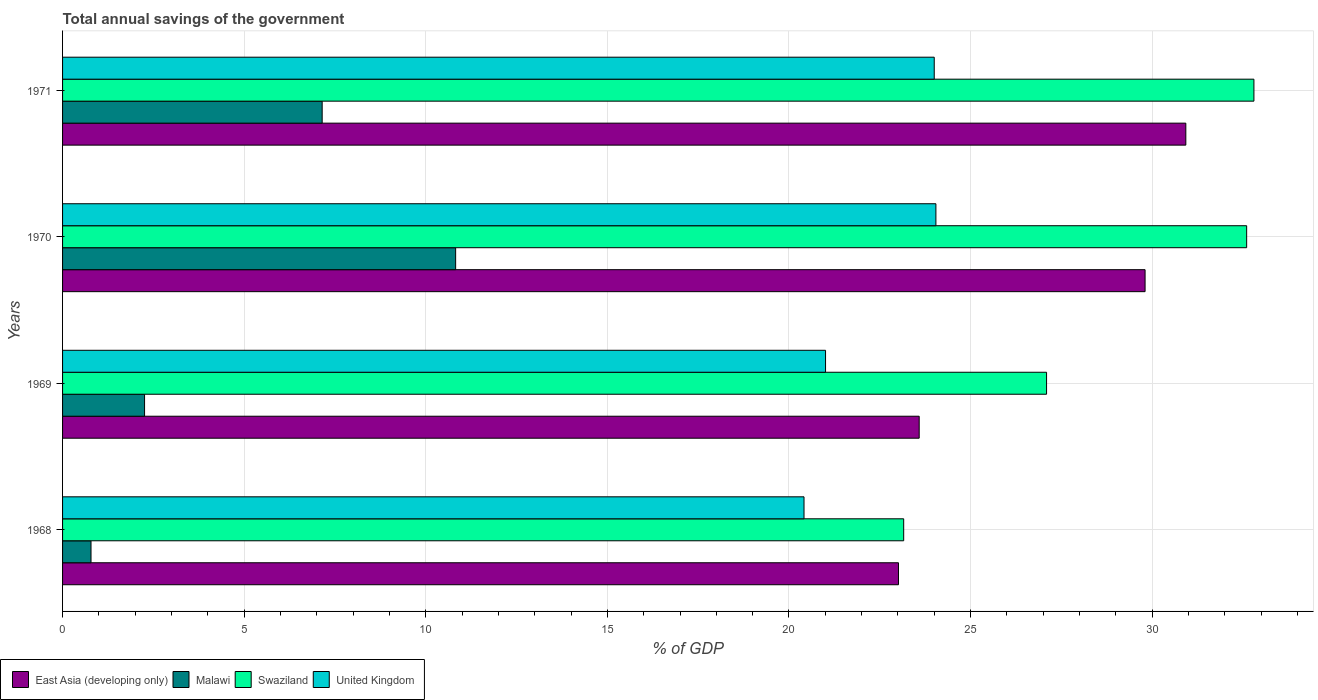How many different coloured bars are there?
Ensure brevity in your answer.  4. How many bars are there on the 4th tick from the bottom?
Your answer should be compact. 4. What is the label of the 2nd group of bars from the top?
Provide a succinct answer. 1970. In how many cases, is the number of bars for a given year not equal to the number of legend labels?
Ensure brevity in your answer.  0. What is the total annual savings of the government in Swaziland in 1968?
Ensure brevity in your answer.  23.16. Across all years, what is the maximum total annual savings of the government in Swaziland?
Give a very brief answer. 32.8. Across all years, what is the minimum total annual savings of the government in East Asia (developing only)?
Offer a terse response. 23.01. In which year was the total annual savings of the government in United Kingdom minimum?
Make the answer very short. 1968. What is the total total annual savings of the government in East Asia (developing only) in the graph?
Offer a very short reply. 107.33. What is the difference between the total annual savings of the government in Malawi in 1969 and that in 1970?
Ensure brevity in your answer.  -8.56. What is the difference between the total annual savings of the government in East Asia (developing only) in 1971 and the total annual savings of the government in Malawi in 1968?
Your answer should be compact. 30.14. What is the average total annual savings of the government in East Asia (developing only) per year?
Your answer should be compact. 26.83. In the year 1968, what is the difference between the total annual savings of the government in East Asia (developing only) and total annual savings of the government in Swaziland?
Offer a very short reply. -0.14. What is the ratio of the total annual savings of the government in East Asia (developing only) in 1968 to that in 1970?
Your response must be concise. 0.77. Is the total annual savings of the government in Malawi in 1969 less than that in 1971?
Offer a terse response. Yes. What is the difference between the highest and the second highest total annual savings of the government in Malawi?
Keep it short and to the point. 3.67. What is the difference between the highest and the lowest total annual savings of the government in United Kingdom?
Your answer should be compact. 3.63. In how many years, is the total annual savings of the government in Malawi greater than the average total annual savings of the government in Malawi taken over all years?
Ensure brevity in your answer.  2. Is the sum of the total annual savings of the government in United Kingdom in 1968 and 1971 greater than the maximum total annual savings of the government in Malawi across all years?
Your answer should be compact. Yes. What does the 2nd bar from the bottom in 1971 represents?
Your answer should be compact. Malawi. Is it the case that in every year, the sum of the total annual savings of the government in Swaziland and total annual savings of the government in East Asia (developing only) is greater than the total annual savings of the government in United Kingdom?
Ensure brevity in your answer.  Yes. How many years are there in the graph?
Your answer should be very brief. 4. Are the values on the major ticks of X-axis written in scientific E-notation?
Your answer should be very brief. No. Does the graph contain any zero values?
Ensure brevity in your answer.  No. Where does the legend appear in the graph?
Provide a succinct answer. Bottom left. How many legend labels are there?
Offer a very short reply. 4. What is the title of the graph?
Provide a short and direct response. Total annual savings of the government. Does "Curacao" appear as one of the legend labels in the graph?
Offer a very short reply. No. What is the label or title of the X-axis?
Your answer should be compact. % of GDP. What is the % of GDP in East Asia (developing only) in 1968?
Ensure brevity in your answer.  23.01. What is the % of GDP in Malawi in 1968?
Offer a terse response. 0.78. What is the % of GDP of Swaziland in 1968?
Offer a terse response. 23.16. What is the % of GDP in United Kingdom in 1968?
Ensure brevity in your answer.  20.41. What is the % of GDP in East Asia (developing only) in 1969?
Offer a terse response. 23.58. What is the % of GDP of Malawi in 1969?
Ensure brevity in your answer.  2.26. What is the % of GDP in Swaziland in 1969?
Provide a short and direct response. 27.09. What is the % of GDP in United Kingdom in 1969?
Provide a succinct answer. 21.01. What is the % of GDP in East Asia (developing only) in 1970?
Offer a very short reply. 29.8. What is the % of GDP in Malawi in 1970?
Make the answer very short. 10.82. What is the % of GDP in Swaziland in 1970?
Offer a very short reply. 32.6. What is the % of GDP in United Kingdom in 1970?
Give a very brief answer. 24.04. What is the % of GDP in East Asia (developing only) in 1971?
Offer a very short reply. 30.93. What is the % of GDP of Malawi in 1971?
Your answer should be compact. 7.15. What is the % of GDP of Swaziland in 1971?
Your answer should be very brief. 32.8. What is the % of GDP in United Kingdom in 1971?
Provide a short and direct response. 24. Across all years, what is the maximum % of GDP in East Asia (developing only)?
Ensure brevity in your answer.  30.93. Across all years, what is the maximum % of GDP of Malawi?
Offer a terse response. 10.82. Across all years, what is the maximum % of GDP in Swaziland?
Ensure brevity in your answer.  32.8. Across all years, what is the maximum % of GDP of United Kingdom?
Offer a terse response. 24.04. Across all years, what is the minimum % of GDP of East Asia (developing only)?
Provide a succinct answer. 23.01. Across all years, what is the minimum % of GDP of Malawi?
Your answer should be compact. 0.78. Across all years, what is the minimum % of GDP of Swaziland?
Ensure brevity in your answer.  23.16. Across all years, what is the minimum % of GDP in United Kingdom?
Provide a succinct answer. 20.41. What is the total % of GDP of East Asia (developing only) in the graph?
Offer a terse response. 107.33. What is the total % of GDP of Malawi in the graph?
Your answer should be compact. 21.01. What is the total % of GDP of Swaziland in the graph?
Your answer should be very brief. 115.65. What is the total % of GDP of United Kingdom in the graph?
Keep it short and to the point. 89.46. What is the difference between the % of GDP in East Asia (developing only) in 1968 and that in 1969?
Your answer should be compact. -0.57. What is the difference between the % of GDP in Malawi in 1968 and that in 1969?
Ensure brevity in your answer.  -1.47. What is the difference between the % of GDP of Swaziland in 1968 and that in 1969?
Keep it short and to the point. -3.93. What is the difference between the % of GDP in United Kingdom in 1968 and that in 1969?
Provide a short and direct response. -0.59. What is the difference between the % of GDP in East Asia (developing only) in 1968 and that in 1970?
Ensure brevity in your answer.  -6.79. What is the difference between the % of GDP in Malawi in 1968 and that in 1970?
Offer a terse response. -10.04. What is the difference between the % of GDP in Swaziland in 1968 and that in 1970?
Provide a short and direct response. -9.44. What is the difference between the % of GDP of United Kingdom in 1968 and that in 1970?
Provide a succinct answer. -3.63. What is the difference between the % of GDP of East Asia (developing only) in 1968 and that in 1971?
Your answer should be compact. -7.91. What is the difference between the % of GDP in Malawi in 1968 and that in 1971?
Provide a short and direct response. -6.36. What is the difference between the % of GDP of Swaziland in 1968 and that in 1971?
Your answer should be compact. -9.64. What is the difference between the % of GDP in United Kingdom in 1968 and that in 1971?
Make the answer very short. -3.59. What is the difference between the % of GDP of East Asia (developing only) in 1969 and that in 1970?
Your response must be concise. -6.22. What is the difference between the % of GDP of Malawi in 1969 and that in 1970?
Offer a terse response. -8.56. What is the difference between the % of GDP of Swaziland in 1969 and that in 1970?
Give a very brief answer. -5.51. What is the difference between the % of GDP of United Kingdom in 1969 and that in 1970?
Provide a short and direct response. -3.04. What is the difference between the % of GDP of East Asia (developing only) in 1969 and that in 1971?
Give a very brief answer. -7.34. What is the difference between the % of GDP of Malawi in 1969 and that in 1971?
Keep it short and to the point. -4.89. What is the difference between the % of GDP of Swaziland in 1969 and that in 1971?
Give a very brief answer. -5.71. What is the difference between the % of GDP of United Kingdom in 1969 and that in 1971?
Make the answer very short. -2.99. What is the difference between the % of GDP in East Asia (developing only) in 1970 and that in 1971?
Keep it short and to the point. -1.12. What is the difference between the % of GDP in Malawi in 1970 and that in 1971?
Keep it short and to the point. 3.67. What is the difference between the % of GDP of Swaziland in 1970 and that in 1971?
Your answer should be compact. -0.2. What is the difference between the % of GDP in United Kingdom in 1970 and that in 1971?
Your response must be concise. 0.05. What is the difference between the % of GDP of East Asia (developing only) in 1968 and the % of GDP of Malawi in 1969?
Provide a succinct answer. 20.76. What is the difference between the % of GDP in East Asia (developing only) in 1968 and the % of GDP in Swaziland in 1969?
Your response must be concise. -4.08. What is the difference between the % of GDP of East Asia (developing only) in 1968 and the % of GDP of United Kingdom in 1969?
Your response must be concise. 2.01. What is the difference between the % of GDP of Malawi in 1968 and the % of GDP of Swaziland in 1969?
Provide a short and direct response. -26.31. What is the difference between the % of GDP in Malawi in 1968 and the % of GDP in United Kingdom in 1969?
Make the answer very short. -20.22. What is the difference between the % of GDP in Swaziland in 1968 and the % of GDP in United Kingdom in 1969?
Make the answer very short. 2.15. What is the difference between the % of GDP of East Asia (developing only) in 1968 and the % of GDP of Malawi in 1970?
Provide a succinct answer. 12.19. What is the difference between the % of GDP in East Asia (developing only) in 1968 and the % of GDP in Swaziland in 1970?
Give a very brief answer. -9.59. What is the difference between the % of GDP of East Asia (developing only) in 1968 and the % of GDP of United Kingdom in 1970?
Your answer should be compact. -1.03. What is the difference between the % of GDP of Malawi in 1968 and the % of GDP of Swaziland in 1970?
Give a very brief answer. -31.82. What is the difference between the % of GDP in Malawi in 1968 and the % of GDP in United Kingdom in 1970?
Provide a short and direct response. -23.26. What is the difference between the % of GDP in Swaziland in 1968 and the % of GDP in United Kingdom in 1970?
Offer a terse response. -0.89. What is the difference between the % of GDP in East Asia (developing only) in 1968 and the % of GDP in Malawi in 1971?
Provide a succinct answer. 15.87. What is the difference between the % of GDP in East Asia (developing only) in 1968 and the % of GDP in Swaziland in 1971?
Provide a short and direct response. -9.79. What is the difference between the % of GDP in East Asia (developing only) in 1968 and the % of GDP in United Kingdom in 1971?
Provide a succinct answer. -0.98. What is the difference between the % of GDP in Malawi in 1968 and the % of GDP in Swaziland in 1971?
Keep it short and to the point. -32.02. What is the difference between the % of GDP of Malawi in 1968 and the % of GDP of United Kingdom in 1971?
Keep it short and to the point. -23.22. What is the difference between the % of GDP of Swaziland in 1968 and the % of GDP of United Kingdom in 1971?
Your response must be concise. -0.84. What is the difference between the % of GDP in East Asia (developing only) in 1969 and the % of GDP in Malawi in 1970?
Your answer should be very brief. 12.76. What is the difference between the % of GDP of East Asia (developing only) in 1969 and the % of GDP of Swaziland in 1970?
Offer a very short reply. -9.02. What is the difference between the % of GDP in East Asia (developing only) in 1969 and the % of GDP in United Kingdom in 1970?
Provide a short and direct response. -0.46. What is the difference between the % of GDP in Malawi in 1969 and the % of GDP in Swaziland in 1970?
Your answer should be very brief. -30.34. What is the difference between the % of GDP of Malawi in 1969 and the % of GDP of United Kingdom in 1970?
Your answer should be very brief. -21.79. What is the difference between the % of GDP in Swaziland in 1969 and the % of GDP in United Kingdom in 1970?
Provide a succinct answer. 3.05. What is the difference between the % of GDP in East Asia (developing only) in 1969 and the % of GDP in Malawi in 1971?
Your response must be concise. 16.44. What is the difference between the % of GDP in East Asia (developing only) in 1969 and the % of GDP in Swaziland in 1971?
Offer a terse response. -9.22. What is the difference between the % of GDP of East Asia (developing only) in 1969 and the % of GDP of United Kingdom in 1971?
Offer a very short reply. -0.41. What is the difference between the % of GDP of Malawi in 1969 and the % of GDP of Swaziland in 1971?
Give a very brief answer. -30.54. What is the difference between the % of GDP of Malawi in 1969 and the % of GDP of United Kingdom in 1971?
Provide a short and direct response. -21.74. What is the difference between the % of GDP in Swaziland in 1969 and the % of GDP in United Kingdom in 1971?
Make the answer very short. 3.09. What is the difference between the % of GDP in East Asia (developing only) in 1970 and the % of GDP in Malawi in 1971?
Your response must be concise. 22.66. What is the difference between the % of GDP of East Asia (developing only) in 1970 and the % of GDP of Swaziland in 1971?
Make the answer very short. -3. What is the difference between the % of GDP of East Asia (developing only) in 1970 and the % of GDP of United Kingdom in 1971?
Your answer should be compact. 5.8. What is the difference between the % of GDP of Malawi in 1970 and the % of GDP of Swaziland in 1971?
Make the answer very short. -21.98. What is the difference between the % of GDP in Malawi in 1970 and the % of GDP in United Kingdom in 1971?
Your response must be concise. -13.18. What is the difference between the % of GDP in Swaziland in 1970 and the % of GDP in United Kingdom in 1971?
Offer a very short reply. 8.6. What is the average % of GDP of East Asia (developing only) per year?
Your answer should be compact. 26.83. What is the average % of GDP in Malawi per year?
Provide a short and direct response. 5.25. What is the average % of GDP of Swaziland per year?
Your answer should be compact. 28.91. What is the average % of GDP of United Kingdom per year?
Keep it short and to the point. 22.37. In the year 1968, what is the difference between the % of GDP in East Asia (developing only) and % of GDP in Malawi?
Ensure brevity in your answer.  22.23. In the year 1968, what is the difference between the % of GDP in East Asia (developing only) and % of GDP in Swaziland?
Ensure brevity in your answer.  -0.14. In the year 1968, what is the difference between the % of GDP of East Asia (developing only) and % of GDP of United Kingdom?
Make the answer very short. 2.6. In the year 1968, what is the difference between the % of GDP of Malawi and % of GDP of Swaziland?
Offer a terse response. -22.37. In the year 1968, what is the difference between the % of GDP in Malawi and % of GDP in United Kingdom?
Give a very brief answer. -19.63. In the year 1968, what is the difference between the % of GDP in Swaziland and % of GDP in United Kingdom?
Give a very brief answer. 2.74. In the year 1969, what is the difference between the % of GDP in East Asia (developing only) and % of GDP in Malawi?
Your response must be concise. 21.33. In the year 1969, what is the difference between the % of GDP of East Asia (developing only) and % of GDP of Swaziland?
Provide a short and direct response. -3.51. In the year 1969, what is the difference between the % of GDP in East Asia (developing only) and % of GDP in United Kingdom?
Keep it short and to the point. 2.58. In the year 1969, what is the difference between the % of GDP in Malawi and % of GDP in Swaziland?
Provide a short and direct response. -24.83. In the year 1969, what is the difference between the % of GDP of Malawi and % of GDP of United Kingdom?
Your answer should be compact. -18.75. In the year 1969, what is the difference between the % of GDP of Swaziland and % of GDP of United Kingdom?
Keep it short and to the point. 6.09. In the year 1970, what is the difference between the % of GDP in East Asia (developing only) and % of GDP in Malawi?
Offer a very short reply. 18.98. In the year 1970, what is the difference between the % of GDP of East Asia (developing only) and % of GDP of Swaziland?
Keep it short and to the point. -2.8. In the year 1970, what is the difference between the % of GDP in East Asia (developing only) and % of GDP in United Kingdom?
Keep it short and to the point. 5.76. In the year 1970, what is the difference between the % of GDP of Malawi and % of GDP of Swaziland?
Make the answer very short. -21.78. In the year 1970, what is the difference between the % of GDP in Malawi and % of GDP in United Kingdom?
Offer a very short reply. -13.22. In the year 1970, what is the difference between the % of GDP in Swaziland and % of GDP in United Kingdom?
Provide a succinct answer. 8.56. In the year 1971, what is the difference between the % of GDP of East Asia (developing only) and % of GDP of Malawi?
Provide a short and direct response. 23.78. In the year 1971, what is the difference between the % of GDP of East Asia (developing only) and % of GDP of Swaziland?
Provide a short and direct response. -1.87. In the year 1971, what is the difference between the % of GDP in East Asia (developing only) and % of GDP in United Kingdom?
Make the answer very short. 6.93. In the year 1971, what is the difference between the % of GDP of Malawi and % of GDP of Swaziland?
Ensure brevity in your answer.  -25.65. In the year 1971, what is the difference between the % of GDP in Malawi and % of GDP in United Kingdom?
Give a very brief answer. -16.85. In the year 1971, what is the difference between the % of GDP of Swaziland and % of GDP of United Kingdom?
Offer a terse response. 8.8. What is the ratio of the % of GDP in East Asia (developing only) in 1968 to that in 1969?
Ensure brevity in your answer.  0.98. What is the ratio of the % of GDP in Malawi in 1968 to that in 1969?
Offer a terse response. 0.35. What is the ratio of the % of GDP of Swaziland in 1968 to that in 1969?
Offer a very short reply. 0.85. What is the ratio of the % of GDP of United Kingdom in 1968 to that in 1969?
Give a very brief answer. 0.97. What is the ratio of the % of GDP in East Asia (developing only) in 1968 to that in 1970?
Offer a very short reply. 0.77. What is the ratio of the % of GDP in Malawi in 1968 to that in 1970?
Provide a succinct answer. 0.07. What is the ratio of the % of GDP in Swaziland in 1968 to that in 1970?
Offer a very short reply. 0.71. What is the ratio of the % of GDP of United Kingdom in 1968 to that in 1970?
Your answer should be compact. 0.85. What is the ratio of the % of GDP in East Asia (developing only) in 1968 to that in 1971?
Give a very brief answer. 0.74. What is the ratio of the % of GDP in Malawi in 1968 to that in 1971?
Provide a short and direct response. 0.11. What is the ratio of the % of GDP of Swaziland in 1968 to that in 1971?
Offer a very short reply. 0.71. What is the ratio of the % of GDP of United Kingdom in 1968 to that in 1971?
Your answer should be very brief. 0.85. What is the ratio of the % of GDP in East Asia (developing only) in 1969 to that in 1970?
Offer a very short reply. 0.79. What is the ratio of the % of GDP in Malawi in 1969 to that in 1970?
Offer a very short reply. 0.21. What is the ratio of the % of GDP in Swaziland in 1969 to that in 1970?
Provide a succinct answer. 0.83. What is the ratio of the % of GDP in United Kingdom in 1969 to that in 1970?
Your answer should be compact. 0.87. What is the ratio of the % of GDP in East Asia (developing only) in 1969 to that in 1971?
Provide a succinct answer. 0.76. What is the ratio of the % of GDP of Malawi in 1969 to that in 1971?
Offer a terse response. 0.32. What is the ratio of the % of GDP in Swaziland in 1969 to that in 1971?
Provide a short and direct response. 0.83. What is the ratio of the % of GDP of United Kingdom in 1969 to that in 1971?
Keep it short and to the point. 0.88. What is the ratio of the % of GDP in East Asia (developing only) in 1970 to that in 1971?
Your answer should be compact. 0.96. What is the ratio of the % of GDP of Malawi in 1970 to that in 1971?
Provide a short and direct response. 1.51. What is the ratio of the % of GDP of Swaziland in 1970 to that in 1971?
Your answer should be very brief. 0.99. What is the difference between the highest and the second highest % of GDP of East Asia (developing only)?
Provide a short and direct response. 1.12. What is the difference between the highest and the second highest % of GDP of Malawi?
Provide a short and direct response. 3.67. What is the difference between the highest and the second highest % of GDP in Swaziland?
Offer a very short reply. 0.2. What is the difference between the highest and the second highest % of GDP of United Kingdom?
Give a very brief answer. 0.05. What is the difference between the highest and the lowest % of GDP in East Asia (developing only)?
Your response must be concise. 7.91. What is the difference between the highest and the lowest % of GDP in Malawi?
Your answer should be very brief. 10.04. What is the difference between the highest and the lowest % of GDP in Swaziland?
Provide a short and direct response. 9.64. What is the difference between the highest and the lowest % of GDP in United Kingdom?
Make the answer very short. 3.63. 